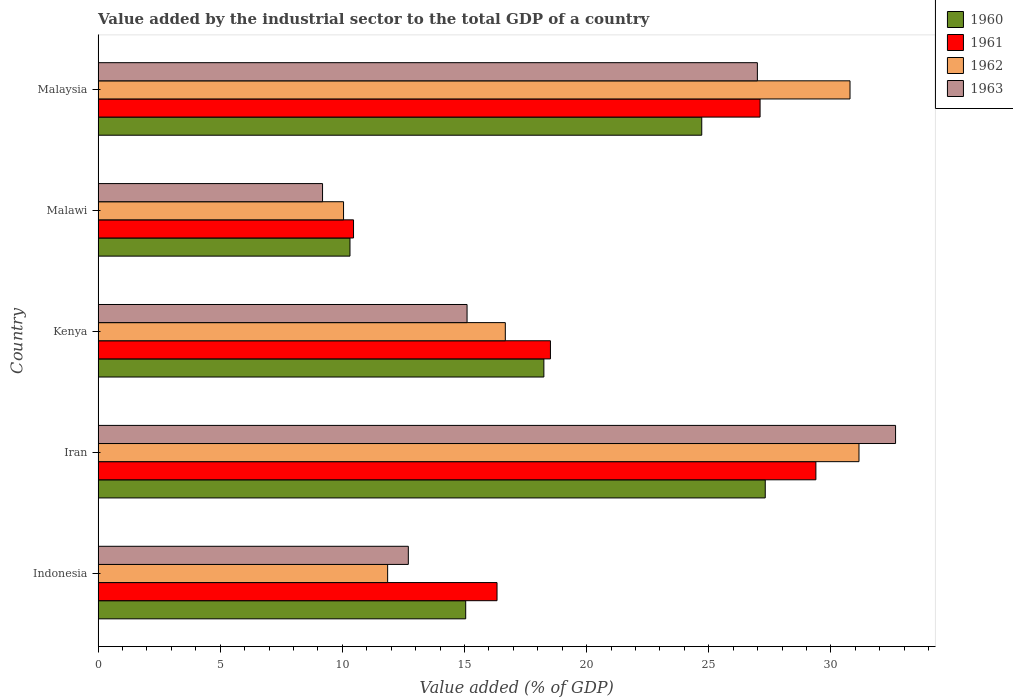How many groups of bars are there?
Keep it short and to the point. 5. How many bars are there on the 4th tick from the top?
Ensure brevity in your answer.  4. How many bars are there on the 2nd tick from the bottom?
Your response must be concise. 4. What is the label of the 2nd group of bars from the top?
Your response must be concise. Malawi. In how many cases, is the number of bars for a given country not equal to the number of legend labels?
Make the answer very short. 0. What is the value added by the industrial sector to the total GDP in 1961 in Kenya?
Give a very brief answer. 18.52. Across all countries, what is the maximum value added by the industrial sector to the total GDP in 1961?
Your answer should be very brief. 29.38. Across all countries, what is the minimum value added by the industrial sector to the total GDP in 1960?
Give a very brief answer. 10.31. In which country was the value added by the industrial sector to the total GDP in 1962 maximum?
Provide a succinct answer. Iran. In which country was the value added by the industrial sector to the total GDP in 1963 minimum?
Provide a short and direct response. Malawi. What is the total value added by the industrial sector to the total GDP in 1960 in the graph?
Provide a succinct answer. 95.63. What is the difference between the value added by the industrial sector to the total GDP in 1960 in Indonesia and that in Malawi?
Give a very brief answer. 4.74. What is the difference between the value added by the industrial sector to the total GDP in 1962 in Malaysia and the value added by the industrial sector to the total GDP in 1963 in Iran?
Provide a succinct answer. -1.86. What is the average value added by the industrial sector to the total GDP in 1962 per country?
Provide a short and direct response. 20.1. What is the difference between the value added by the industrial sector to the total GDP in 1962 and value added by the industrial sector to the total GDP in 1961 in Malaysia?
Make the answer very short. 3.68. What is the ratio of the value added by the industrial sector to the total GDP in 1961 in Malawi to that in Malaysia?
Keep it short and to the point. 0.39. Is the value added by the industrial sector to the total GDP in 1963 in Indonesia less than that in Malawi?
Your response must be concise. No. What is the difference between the highest and the second highest value added by the industrial sector to the total GDP in 1963?
Offer a very short reply. 5.66. What is the difference between the highest and the lowest value added by the industrial sector to the total GDP in 1963?
Your response must be concise. 23.46. Is it the case that in every country, the sum of the value added by the industrial sector to the total GDP in 1961 and value added by the industrial sector to the total GDP in 1962 is greater than the sum of value added by the industrial sector to the total GDP in 1963 and value added by the industrial sector to the total GDP in 1960?
Your answer should be very brief. No. What does the 2nd bar from the top in Indonesia represents?
Your answer should be compact. 1962. Does the graph contain any zero values?
Your answer should be very brief. No. Does the graph contain grids?
Your response must be concise. No. How are the legend labels stacked?
Give a very brief answer. Vertical. What is the title of the graph?
Offer a very short reply. Value added by the industrial sector to the total GDP of a country. Does "2013" appear as one of the legend labels in the graph?
Provide a succinct answer. No. What is the label or title of the X-axis?
Your response must be concise. Value added (% of GDP). What is the Value added (% of GDP) in 1960 in Indonesia?
Make the answer very short. 15.05. What is the Value added (% of GDP) of 1961 in Indonesia?
Provide a short and direct response. 16.33. What is the Value added (% of GDP) of 1962 in Indonesia?
Keep it short and to the point. 11.85. What is the Value added (% of GDP) in 1963 in Indonesia?
Offer a terse response. 12.7. What is the Value added (% of GDP) of 1960 in Iran?
Provide a succinct answer. 27.31. What is the Value added (% of GDP) of 1961 in Iran?
Your answer should be compact. 29.38. What is the Value added (% of GDP) of 1962 in Iran?
Give a very brief answer. 31.15. What is the Value added (% of GDP) of 1963 in Iran?
Your answer should be compact. 32.65. What is the Value added (% of GDP) of 1960 in Kenya?
Offer a terse response. 18.25. What is the Value added (% of GDP) of 1961 in Kenya?
Your response must be concise. 18.52. What is the Value added (% of GDP) of 1962 in Kenya?
Provide a short and direct response. 16.67. What is the Value added (% of GDP) of 1963 in Kenya?
Provide a succinct answer. 15.1. What is the Value added (% of GDP) in 1960 in Malawi?
Ensure brevity in your answer.  10.31. What is the Value added (% of GDP) of 1961 in Malawi?
Provide a short and direct response. 10.46. What is the Value added (% of GDP) of 1962 in Malawi?
Offer a terse response. 10.05. What is the Value added (% of GDP) in 1963 in Malawi?
Give a very brief answer. 9.19. What is the Value added (% of GDP) of 1960 in Malaysia?
Your answer should be very brief. 24.71. What is the Value added (% of GDP) in 1961 in Malaysia?
Provide a succinct answer. 27.1. What is the Value added (% of GDP) in 1962 in Malaysia?
Give a very brief answer. 30.78. What is the Value added (% of GDP) in 1963 in Malaysia?
Give a very brief answer. 26.99. Across all countries, what is the maximum Value added (% of GDP) in 1960?
Your answer should be very brief. 27.31. Across all countries, what is the maximum Value added (% of GDP) of 1961?
Your response must be concise. 29.38. Across all countries, what is the maximum Value added (% of GDP) in 1962?
Keep it short and to the point. 31.15. Across all countries, what is the maximum Value added (% of GDP) in 1963?
Your answer should be compact. 32.65. Across all countries, what is the minimum Value added (% of GDP) of 1960?
Your response must be concise. 10.31. Across all countries, what is the minimum Value added (% of GDP) of 1961?
Offer a very short reply. 10.46. Across all countries, what is the minimum Value added (% of GDP) of 1962?
Offer a very short reply. 10.05. Across all countries, what is the minimum Value added (% of GDP) of 1963?
Give a very brief answer. 9.19. What is the total Value added (% of GDP) in 1960 in the graph?
Your answer should be compact. 95.63. What is the total Value added (% of GDP) of 1961 in the graph?
Keep it short and to the point. 101.79. What is the total Value added (% of GDP) in 1962 in the graph?
Make the answer very short. 100.5. What is the total Value added (% of GDP) in 1963 in the graph?
Give a very brief answer. 96.63. What is the difference between the Value added (% of GDP) in 1960 in Indonesia and that in Iran?
Keep it short and to the point. -12.26. What is the difference between the Value added (% of GDP) in 1961 in Indonesia and that in Iran?
Make the answer very short. -13.05. What is the difference between the Value added (% of GDP) in 1962 in Indonesia and that in Iran?
Your response must be concise. -19.3. What is the difference between the Value added (% of GDP) in 1963 in Indonesia and that in Iran?
Provide a short and direct response. -19.95. What is the difference between the Value added (% of GDP) in 1960 in Indonesia and that in Kenya?
Offer a very short reply. -3.2. What is the difference between the Value added (% of GDP) in 1961 in Indonesia and that in Kenya?
Ensure brevity in your answer.  -2.19. What is the difference between the Value added (% of GDP) of 1962 in Indonesia and that in Kenya?
Give a very brief answer. -4.82. What is the difference between the Value added (% of GDP) of 1963 in Indonesia and that in Kenya?
Give a very brief answer. -2.4. What is the difference between the Value added (% of GDP) in 1960 in Indonesia and that in Malawi?
Offer a very short reply. 4.74. What is the difference between the Value added (% of GDP) of 1961 in Indonesia and that in Malawi?
Give a very brief answer. 5.87. What is the difference between the Value added (% of GDP) of 1962 in Indonesia and that in Malawi?
Ensure brevity in your answer.  1.8. What is the difference between the Value added (% of GDP) of 1963 in Indonesia and that in Malawi?
Make the answer very short. 3.51. What is the difference between the Value added (% of GDP) in 1960 in Indonesia and that in Malaysia?
Make the answer very short. -9.66. What is the difference between the Value added (% of GDP) of 1961 in Indonesia and that in Malaysia?
Your answer should be compact. -10.77. What is the difference between the Value added (% of GDP) in 1962 in Indonesia and that in Malaysia?
Provide a short and direct response. -18.93. What is the difference between the Value added (% of GDP) in 1963 in Indonesia and that in Malaysia?
Your response must be concise. -14.29. What is the difference between the Value added (% of GDP) of 1960 in Iran and that in Kenya?
Offer a terse response. 9.06. What is the difference between the Value added (% of GDP) of 1961 in Iran and that in Kenya?
Offer a very short reply. 10.87. What is the difference between the Value added (% of GDP) in 1962 in Iran and that in Kenya?
Your answer should be very brief. 14.48. What is the difference between the Value added (% of GDP) in 1963 in Iran and that in Kenya?
Provide a short and direct response. 17.54. What is the difference between the Value added (% of GDP) of 1960 in Iran and that in Malawi?
Your response must be concise. 17. What is the difference between the Value added (% of GDP) of 1961 in Iran and that in Malawi?
Offer a very short reply. 18.93. What is the difference between the Value added (% of GDP) of 1962 in Iran and that in Malawi?
Provide a succinct answer. 21.1. What is the difference between the Value added (% of GDP) in 1963 in Iran and that in Malawi?
Offer a very short reply. 23.46. What is the difference between the Value added (% of GDP) of 1960 in Iran and that in Malaysia?
Provide a succinct answer. 2.6. What is the difference between the Value added (% of GDP) in 1961 in Iran and that in Malaysia?
Provide a short and direct response. 2.29. What is the difference between the Value added (% of GDP) of 1962 in Iran and that in Malaysia?
Give a very brief answer. 0.37. What is the difference between the Value added (% of GDP) of 1963 in Iran and that in Malaysia?
Your answer should be very brief. 5.66. What is the difference between the Value added (% of GDP) in 1960 in Kenya and that in Malawi?
Offer a terse response. 7.94. What is the difference between the Value added (% of GDP) in 1961 in Kenya and that in Malawi?
Ensure brevity in your answer.  8.06. What is the difference between the Value added (% of GDP) of 1962 in Kenya and that in Malawi?
Make the answer very short. 6.62. What is the difference between the Value added (% of GDP) in 1963 in Kenya and that in Malawi?
Offer a very short reply. 5.92. What is the difference between the Value added (% of GDP) in 1960 in Kenya and that in Malaysia?
Make the answer very short. -6.46. What is the difference between the Value added (% of GDP) of 1961 in Kenya and that in Malaysia?
Offer a very short reply. -8.58. What is the difference between the Value added (% of GDP) of 1962 in Kenya and that in Malaysia?
Offer a terse response. -14.11. What is the difference between the Value added (% of GDP) of 1963 in Kenya and that in Malaysia?
Ensure brevity in your answer.  -11.88. What is the difference between the Value added (% of GDP) of 1960 in Malawi and that in Malaysia?
Provide a short and direct response. -14.4. What is the difference between the Value added (% of GDP) of 1961 in Malawi and that in Malaysia?
Ensure brevity in your answer.  -16.64. What is the difference between the Value added (% of GDP) in 1962 in Malawi and that in Malaysia?
Make the answer very short. -20.73. What is the difference between the Value added (% of GDP) of 1963 in Malawi and that in Malaysia?
Your response must be concise. -17.8. What is the difference between the Value added (% of GDP) in 1960 in Indonesia and the Value added (% of GDP) in 1961 in Iran?
Offer a terse response. -14.34. What is the difference between the Value added (% of GDP) in 1960 in Indonesia and the Value added (% of GDP) in 1962 in Iran?
Provide a short and direct response. -16.1. What is the difference between the Value added (% of GDP) in 1960 in Indonesia and the Value added (% of GDP) in 1963 in Iran?
Provide a succinct answer. -17.6. What is the difference between the Value added (% of GDP) in 1961 in Indonesia and the Value added (% of GDP) in 1962 in Iran?
Offer a terse response. -14.82. What is the difference between the Value added (% of GDP) of 1961 in Indonesia and the Value added (% of GDP) of 1963 in Iran?
Your answer should be compact. -16.32. What is the difference between the Value added (% of GDP) of 1962 in Indonesia and the Value added (% of GDP) of 1963 in Iran?
Offer a terse response. -20.79. What is the difference between the Value added (% of GDP) of 1960 in Indonesia and the Value added (% of GDP) of 1961 in Kenya?
Ensure brevity in your answer.  -3.47. What is the difference between the Value added (% of GDP) of 1960 in Indonesia and the Value added (% of GDP) of 1962 in Kenya?
Your answer should be very brief. -1.62. What is the difference between the Value added (% of GDP) of 1960 in Indonesia and the Value added (% of GDP) of 1963 in Kenya?
Offer a terse response. -0.06. What is the difference between the Value added (% of GDP) of 1961 in Indonesia and the Value added (% of GDP) of 1962 in Kenya?
Provide a succinct answer. -0.34. What is the difference between the Value added (% of GDP) of 1961 in Indonesia and the Value added (% of GDP) of 1963 in Kenya?
Make the answer very short. 1.23. What is the difference between the Value added (% of GDP) of 1962 in Indonesia and the Value added (% of GDP) of 1963 in Kenya?
Keep it short and to the point. -3.25. What is the difference between the Value added (% of GDP) in 1960 in Indonesia and the Value added (% of GDP) in 1961 in Malawi?
Ensure brevity in your answer.  4.59. What is the difference between the Value added (% of GDP) in 1960 in Indonesia and the Value added (% of GDP) in 1962 in Malawi?
Give a very brief answer. 5. What is the difference between the Value added (% of GDP) in 1960 in Indonesia and the Value added (% of GDP) in 1963 in Malawi?
Provide a succinct answer. 5.86. What is the difference between the Value added (% of GDP) of 1961 in Indonesia and the Value added (% of GDP) of 1962 in Malawi?
Give a very brief answer. 6.28. What is the difference between the Value added (% of GDP) of 1961 in Indonesia and the Value added (% of GDP) of 1963 in Malawi?
Keep it short and to the point. 7.14. What is the difference between the Value added (% of GDP) in 1962 in Indonesia and the Value added (% of GDP) in 1963 in Malawi?
Your answer should be compact. 2.66. What is the difference between the Value added (% of GDP) of 1960 in Indonesia and the Value added (% of GDP) of 1961 in Malaysia?
Your answer should be compact. -12.05. What is the difference between the Value added (% of GDP) in 1960 in Indonesia and the Value added (% of GDP) in 1962 in Malaysia?
Provide a succinct answer. -15.73. What is the difference between the Value added (% of GDP) of 1960 in Indonesia and the Value added (% of GDP) of 1963 in Malaysia?
Give a very brief answer. -11.94. What is the difference between the Value added (% of GDP) in 1961 in Indonesia and the Value added (% of GDP) in 1962 in Malaysia?
Give a very brief answer. -14.45. What is the difference between the Value added (% of GDP) of 1961 in Indonesia and the Value added (% of GDP) of 1963 in Malaysia?
Make the answer very short. -10.66. What is the difference between the Value added (% of GDP) of 1962 in Indonesia and the Value added (% of GDP) of 1963 in Malaysia?
Offer a terse response. -15.14. What is the difference between the Value added (% of GDP) of 1960 in Iran and the Value added (% of GDP) of 1961 in Kenya?
Give a very brief answer. 8.79. What is the difference between the Value added (% of GDP) of 1960 in Iran and the Value added (% of GDP) of 1962 in Kenya?
Your answer should be very brief. 10.64. What is the difference between the Value added (% of GDP) of 1960 in Iran and the Value added (% of GDP) of 1963 in Kenya?
Offer a terse response. 12.21. What is the difference between the Value added (% of GDP) of 1961 in Iran and the Value added (% of GDP) of 1962 in Kenya?
Your answer should be very brief. 12.71. What is the difference between the Value added (% of GDP) of 1961 in Iran and the Value added (% of GDP) of 1963 in Kenya?
Your answer should be compact. 14.28. What is the difference between the Value added (% of GDP) in 1962 in Iran and the Value added (% of GDP) in 1963 in Kenya?
Give a very brief answer. 16.04. What is the difference between the Value added (% of GDP) of 1960 in Iran and the Value added (% of GDP) of 1961 in Malawi?
Provide a short and direct response. 16.86. What is the difference between the Value added (% of GDP) in 1960 in Iran and the Value added (% of GDP) in 1962 in Malawi?
Your answer should be very brief. 17.26. What is the difference between the Value added (% of GDP) of 1960 in Iran and the Value added (% of GDP) of 1963 in Malawi?
Keep it short and to the point. 18.12. What is the difference between the Value added (% of GDP) of 1961 in Iran and the Value added (% of GDP) of 1962 in Malawi?
Keep it short and to the point. 19.34. What is the difference between the Value added (% of GDP) in 1961 in Iran and the Value added (% of GDP) in 1963 in Malawi?
Keep it short and to the point. 20.2. What is the difference between the Value added (% of GDP) of 1962 in Iran and the Value added (% of GDP) of 1963 in Malawi?
Your answer should be very brief. 21.96. What is the difference between the Value added (% of GDP) of 1960 in Iran and the Value added (% of GDP) of 1961 in Malaysia?
Make the answer very short. 0.21. What is the difference between the Value added (% of GDP) of 1960 in Iran and the Value added (% of GDP) of 1962 in Malaysia?
Keep it short and to the point. -3.47. What is the difference between the Value added (% of GDP) in 1960 in Iran and the Value added (% of GDP) in 1963 in Malaysia?
Keep it short and to the point. 0.32. What is the difference between the Value added (% of GDP) in 1961 in Iran and the Value added (% of GDP) in 1962 in Malaysia?
Offer a very short reply. -1.4. What is the difference between the Value added (% of GDP) in 1961 in Iran and the Value added (% of GDP) in 1963 in Malaysia?
Provide a short and direct response. 2.4. What is the difference between the Value added (% of GDP) of 1962 in Iran and the Value added (% of GDP) of 1963 in Malaysia?
Your answer should be very brief. 4.16. What is the difference between the Value added (% of GDP) in 1960 in Kenya and the Value added (% of GDP) in 1961 in Malawi?
Keep it short and to the point. 7.79. What is the difference between the Value added (% of GDP) in 1960 in Kenya and the Value added (% of GDP) in 1962 in Malawi?
Your answer should be compact. 8.2. What is the difference between the Value added (% of GDP) of 1960 in Kenya and the Value added (% of GDP) of 1963 in Malawi?
Your answer should be very brief. 9.06. What is the difference between the Value added (% of GDP) in 1961 in Kenya and the Value added (% of GDP) in 1962 in Malawi?
Provide a succinct answer. 8.47. What is the difference between the Value added (% of GDP) of 1961 in Kenya and the Value added (% of GDP) of 1963 in Malawi?
Your answer should be compact. 9.33. What is the difference between the Value added (% of GDP) in 1962 in Kenya and the Value added (% of GDP) in 1963 in Malawi?
Offer a terse response. 7.48. What is the difference between the Value added (% of GDP) in 1960 in Kenya and the Value added (% of GDP) in 1961 in Malaysia?
Your response must be concise. -8.85. What is the difference between the Value added (% of GDP) of 1960 in Kenya and the Value added (% of GDP) of 1962 in Malaysia?
Your answer should be compact. -12.53. What is the difference between the Value added (% of GDP) in 1960 in Kenya and the Value added (% of GDP) in 1963 in Malaysia?
Your answer should be compact. -8.74. What is the difference between the Value added (% of GDP) in 1961 in Kenya and the Value added (% of GDP) in 1962 in Malaysia?
Make the answer very short. -12.26. What is the difference between the Value added (% of GDP) in 1961 in Kenya and the Value added (% of GDP) in 1963 in Malaysia?
Provide a short and direct response. -8.47. What is the difference between the Value added (% of GDP) in 1962 in Kenya and the Value added (% of GDP) in 1963 in Malaysia?
Give a very brief answer. -10.32. What is the difference between the Value added (% of GDP) of 1960 in Malawi and the Value added (% of GDP) of 1961 in Malaysia?
Your answer should be very brief. -16.79. What is the difference between the Value added (% of GDP) in 1960 in Malawi and the Value added (% of GDP) in 1962 in Malaysia?
Give a very brief answer. -20.47. What is the difference between the Value added (% of GDP) of 1960 in Malawi and the Value added (% of GDP) of 1963 in Malaysia?
Your answer should be very brief. -16.68. What is the difference between the Value added (% of GDP) in 1961 in Malawi and the Value added (% of GDP) in 1962 in Malaysia?
Give a very brief answer. -20.33. What is the difference between the Value added (% of GDP) of 1961 in Malawi and the Value added (% of GDP) of 1963 in Malaysia?
Make the answer very short. -16.53. What is the difference between the Value added (% of GDP) of 1962 in Malawi and the Value added (% of GDP) of 1963 in Malaysia?
Offer a terse response. -16.94. What is the average Value added (% of GDP) of 1960 per country?
Make the answer very short. 19.13. What is the average Value added (% of GDP) of 1961 per country?
Your answer should be very brief. 20.36. What is the average Value added (% of GDP) in 1962 per country?
Ensure brevity in your answer.  20.1. What is the average Value added (% of GDP) in 1963 per country?
Provide a succinct answer. 19.33. What is the difference between the Value added (% of GDP) of 1960 and Value added (% of GDP) of 1961 in Indonesia?
Provide a short and direct response. -1.28. What is the difference between the Value added (% of GDP) of 1960 and Value added (% of GDP) of 1962 in Indonesia?
Keep it short and to the point. 3.2. What is the difference between the Value added (% of GDP) in 1960 and Value added (% of GDP) in 1963 in Indonesia?
Your answer should be compact. 2.35. What is the difference between the Value added (% of GDP) of 1961 and Value added (% of GDP) of 1962 in Indonesia?
Provide a short and direct response. 4.48. What is the difference between the Value added (% of GDP) of 1961 and Value added (% of GDP) of 1963 in Indonesia?
Offer a very short reply. 3.63. What is the difference between the Value added (% of GDP) in 1962 and Value added (% of GDP) in 1963 in Indonesia?
Keep it short and to the point. -0.85. What is the difference between the Value added (% of GDP) in 1960 and Value added (% of GDP) in 1961 in Iran?
Give a very brief answer. -2.07. What is the difference between the Value added (% of GDP) of 1960 and Value added (% of GDP) of 1962 in Iran?
Your response must be concise. -3.84. What is the difference between the Value added (% of GDP) of 1960 and Value added (% of GDP) of 1963 in Iran?
Offer a terse response. -5.33. What is the difference between the Value added (% of GDP) of 1961 and Value added (% of GDP) of 1962 in Iran?
Provide a succinct answer. -1.76. What is the difference between the Value added (% of GDP) of 1961 and Value added (% of GDP) of 1963 in Iran?
Make the answer very short. -3.26. What is the difference between the Value added (% of GDP) in 1962 and Value added (% of GDP) in 1963 in Iran?
Provide a short and direct response. -1.5. What is the difference between the Value added (% of GDP) of 1960 and Value added (% of GDP) of 1961 in Kenya?
Your answer should be compact. -0.27. What is the difference between the Value added (% of GDP) of 1960 and Value added (% of GDP) of 1962 in Kenya?
Your response must be concise. 1.58. What is the difference between the Value added (% of GDP) of 1960 and Value added (% of GDP) of 1963 in Kenya?
Make the answer very short. 3.14. What is the difference between the Value added (% of GDP) in 1961 and Value added (% of GDP) in 1962 in Kenya?
Provide a succinct answer. 1.85. What is the difference between the Value added (% of GDP) in 1961 and Value added (% of GDP) in 1963 in Kenya?
Make the answer very short. 3.41. What is the difference between the Value added (% of GDP) in 1962 and Value added (% of GDP) in 1963 in Kenya?
Give a very brief answer. 1.57. What is the difference between the Value added (% of GDP) in 1960 and Value added (% of GDP) in 1961 in Malawi?
Your answer should be compact. -0.15. What is the difference between the Value added (% of GDP) in 1960 and Value added (% of GDP) in 1962 in Malawi?
Your answer should be very brief. 0.26. What is the difference between the Value added (% of GDP) of 1960 and Value added (% of GDP) of 1963 in Malawi?
Ensure brevity in your answer.  1.12. What is the difference between the Value added (% of GDP) of 1961 and Value added (% of GDP) of 1962 in Malawi?
Your answer should be compact. 0.41. What is the difference between the Value added (% of GDP) in 1961 and Value added (% of GDP) in 1963 in Malawi?
Give a very brief answer. 1.27. What is the difference between the Value added (% of GDP) of 1962 and Value added (% of GDP) of 1963 in Malawi?
Ensure brevity in your answer.  0.86. What is the difference between the Value added (% of GDP) in 1960 and Value added (% of GDP) in 1961 in Malaysia?
Your answer should be compact. -2.39. What is the difference between the Value added (% of GDP) of 1960 and Value added (% of GDP) of 1962 in Malaysia?
Provide a succinct answer. -6.07. What is the difference between the Value added (% of GDP) of 1960 and Value added (% of GDP) of 1963 in Malaysia?
Ensure brevity in your answer.  -2.28. What is the difference between the Value added (% of GDP) of 1961 and Value added (% of GDP) of 1962 in Malaysia?
Offer a terse response. -3.68. What is the difference between the Value added (% of GDP) in 1961 and Value added (% of GDP) in 1963 in Malaysia?
Keep it short and to the point. 0.11. What is the difference between the Value added (% of GDP) in 1962 and Value added (% of GDP) in 1963 in Malaysia?
Provide a short and direct response. 3.79. What is the ratio of the Value added (% of GDP) in 1960 in Indonesia to that in Iran?
Offer a very short reply. 0.55. What is the ratio of the Value added (% of GDP) of 1961 in Indonesia to that in Iran?
Provide a short and direct response. 0.56. What is the ratio of the Value added (% of GDP) of 1962 in Indonesia to that in Iran?
Your answer should be compact. 0.38. What is the ratio of the Value added (% of GDP) of 1963 in Indonesia to that in Iran?
Give a very brief answer. 0.39. What is the ratio of the Value added (% of GDP) in 1960 in Indonesia to that in Kenya?
Offer a very short reply. 0.82. What is the ratio of the Value added (% of GDP) in 1961 in Indonesia to that in Kenya?
Offer a terse response. 0.88. What is the ratio of the Value added (% of GDP) in 1962 in Indonesia to that in Kenya?
Your answer should be compact. 0.71. What is the ratio of the Value added (% of GDP) in 1963 in Indonesia to that in Kenya?
Make the answer very short. 0.84. What is the ratio of the Value added (% of GDP) in 1960 in Indonesia to that in Malawi?
Your answer should be compact. 1.46. What is the ratio of the Value added (% of GDP) in 1961 in Indonesia to that in Malawi?
Keep it short and to the point. 1.56. What is the ratio of the Value added (% of GDP) in 1962 in Indonesia to that in Malawi?
Your answer should be very brief. 1.18. What is the ratio of the Value added (% of GDP) in 1963 in Indonesia to that in Malawi?
Provide a succinct answer. 1.38. What is the ratio of the Value added (% of GDP) of 1960 in Indonesia to that in Malaysia?
Ensure brevity in your answer.  0.61. What is the ratio of the Value added (% of GDP) in 1961 in Indonesia to that in Malaysia?
Provide a succinct answer. 0.6. What is the ratio of the Value added (% of GDP) in 1962 in Indonesia to that in Malaysia?
Provide a short and direct response. 0.39. What is the ratio of the Value added (% of GDP) of 1963 in Indonesia to that in Malaysia?
Your answer should be very brief. 0.47. What is the ratio of the Value added (% of GDP) of 1960 in Iran to that in Kenya?
Ensure brevity in your answer.  1.5. What is the ratio of the Value added (% of GDP) in 1961 in Iran to that in Kenya?
Keep it short and to the point. 1.59. What is the ratio of the Value added (% of GDP) in 1962 in Iran to that in Kenya?
Offer a very short reply. 1.87. What is the ratio of the Value added (% of GDP) in 1963 in Iran to that in Kenya?
Make the answer very short. 2.16. What is the ratio of the Value added (% of GDP) in 1960 in Iran to that in Malawi?
Your answer should be compact. 2.65. What is the ratio of the Value added (% of GDP) in 1961 in Iran to that in Malawi?
Provide a short and direct response. 2.81. What is the ratio of the Value added (% of GDP) in 1962 in Iran to that in Malawi?
Offer a terse response. 3.1. What is the ratio of the Value added (% of GDP) in 1963 in Iran to that in Malawi?
Keep it short and to the point. 3.55. What is the ratio of the Value added (% of GDP) in 1960 in Iran to that in Malaysia?
Keep it short and to the point. 1.11. What is the ratio of the Value added (% of GDP) of 1961 in Iran to that in Malaysia?
Your answer should be very brief. 1.08. What is the ratio of the Value added (% of GDP) of 1962 in Iran to that in Malaysia?
Give a very brief answer. 1.01. What is the ratio of the Value added (% of GDP) in 1963 in Iran to that in Malaysia?
Provide a short and direct response. 1.21. What is the ratio of the Value added (% of GDP) in 1960 in Kenya to that in Malawi?
Offer a terse response. 1.77. What is the ratio of the Value added (% of GDP) of 1961 in Kenya to that in Malawi?
Ensure brevity in your answer.  1.77. What is the ratio of the Value added (% of GDP) of 1962 in Kenya to that in Malawi?
Provide a short and direct response. 1.66. What is the ratio of the Value added (% of GDP) of 1963 in Kenya to that in Malawi?
Make the answer very short. 1.64. What is the ratio of the Value added (% of GDP) in 1960 in Kenya to that in Malaysia?
Provide a succinct answer. 0.74. What is the ratio of the Value added (% of GDP) of 1961 in Kenya to that in Malaysia?
Give a very brief answer. 0.68. What is the ratio of the Value added (% of GDP) of 1962 in Kenya to that in Malaysia?
Offer a very short reply. 0.54. What is the ratio of the Value added (% of GDP) of 1963 in Kenya to that in Malaysia?
Your answer should be compact. 0.56. What is the ratio of the Value added (% of GDP) of 1960 in Malawi to that in Malaysia?
Make the answer very short. 0.42. What is the ratio of the Value added (% of GDP) in 1961 in Malawi to that in Malaysia?
Ensure brevity in your answer.  0.39. What is the ratio of the Value added (% of GDP) in 1962 in Malawi to that in Malaysia?
Offer a very short reply. 0.33. What is the ratio of the Value added (% of GDP) in 1963 in Malawi to that in Malaysia?
Keep it short and to the point. 0.34. What is the difference between the highest and the second highest Value added (% of GDP) in 1960?
Provide a short and direct response. 2.6. What is the difference between the highest and the second highest Value added (% of GDP) in 1961?
Make the answer very short. 2.29. What is the difference between the highest and the second highest Value added (% of GDP) of 1962?
Offer a very short reply. 0.37. What is the difference between the highest and the second highest Value added (% of GDP) in 1963?
Provide a short and direct response. 5.66. What is the difference between the highest and the lowest Value added (% of GDP) in 1960?
Your answer should be compact. 17. What is the difference between the highest and the lowest Value added (% of GDP) of 1961?
Your response must be concise. 18.93. What is the difference between the highest and the lowest Value added (% of GDP) in 1962?
Your answer should be compact. 21.1. What is the difference between the highest and the lowest Value added (% of GDP) of 1963?
Your response must be concise. 23.46. 